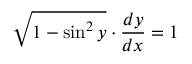<formula> <loc_0><loc_0><loc_500><loc_500>{ \sqrt { 1 - \sin ^ { 2 } y } } \cdot { \frac { d y } { d x } } = 1</formula> 